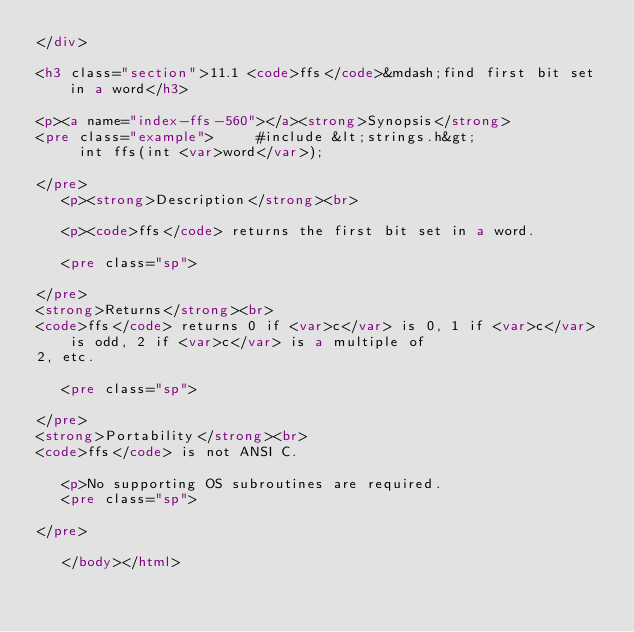Convert code to text. <code><loc_0><loc_0><loc_500><loc_500><_HTML_></div>

<h3 class="section">11.1 <code>ffs</code>&mdash;find first bit set in a word</h3>

<p><a name="index-ffs-560"></a><strong>Synopsis</strong>
<pre class="example">     #include &lt;strings.h&gt;
     int ffs(int <var>word</var>);
     
</pre>
   <p><strong>Description</strong><br>

   <p><code>ffs</code> returns the first bit set in a word.

   <pre class="sp">

</pre>
<strong>Returns</strong><br>
<code>ffs</code> returns 0 if <var>c</var> is 0, 1 if <var>c</var> is odd, 2 if <var>c</var> is a multiple of
2, etc.

   <pre class="sp">

</pre>
<strong>Portability</strong><br>
<code>ffs</code> is not ANSI C.

   <p>No supporting OS subroutines are required.
   <pre class="sp">

</pre>

   </body></html>

</code> 